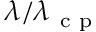Convert formula to latex. <formula><loc_0><loc_0><loc_500><loc_500>\lambda / \lambda _ { c p }</formula> 